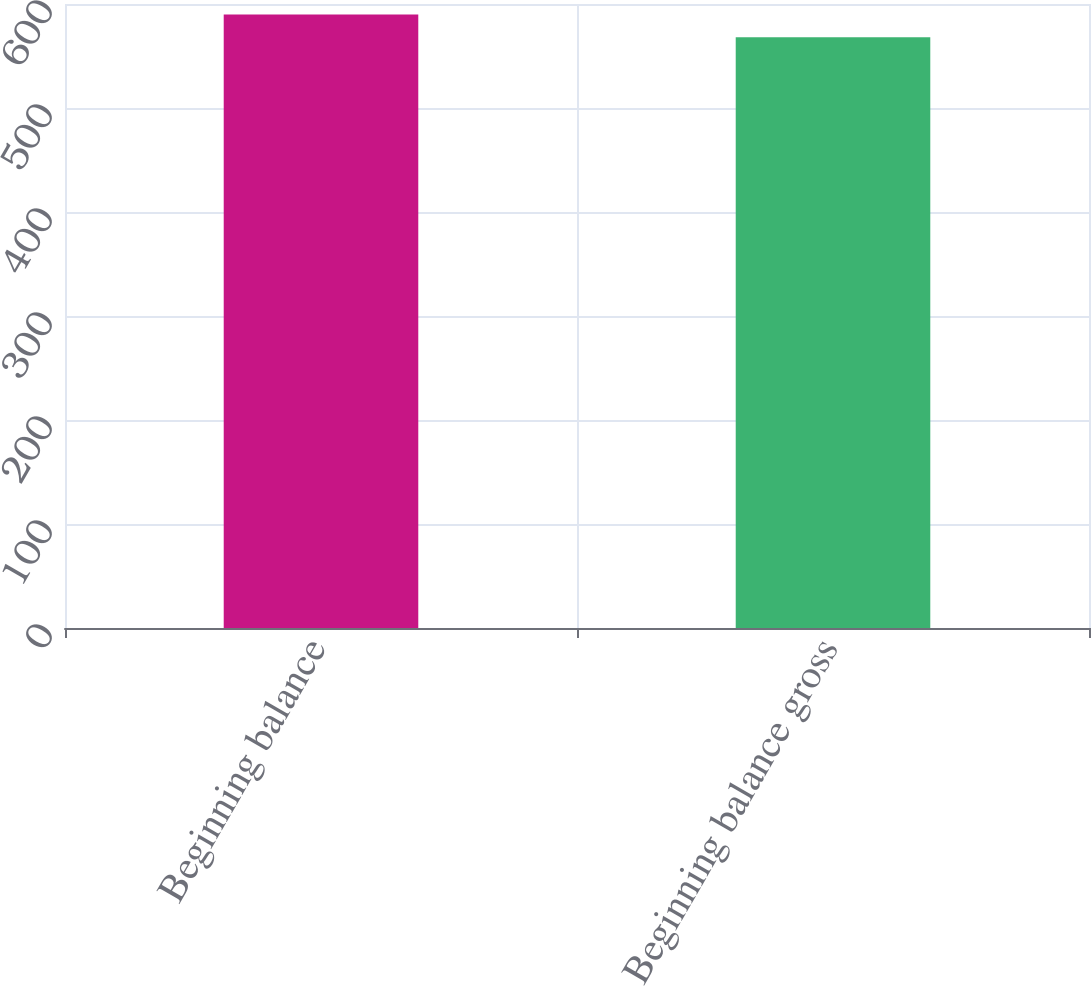Convert chart. <chart><loc_0><loc_0><loc_500><loc_500><bar_chart><fcel>Beginning balance<fcel>Beginning balance gross<nl><fcel>590<fcel>568<nl></chart> 